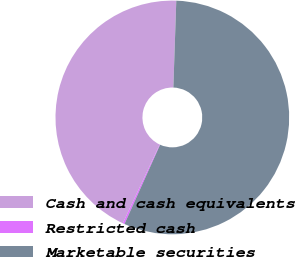Convert chart to OTSL. <chart><loc_0><loc_0><loc_500><loc_500><pie_chart><fcel>Cash and cash equivalents<fcel>Restricted cash<fcel>Marketable securities<nl><fcel>43.57%<fcel>0.25%<fcel>56.18%<nl></chart> 